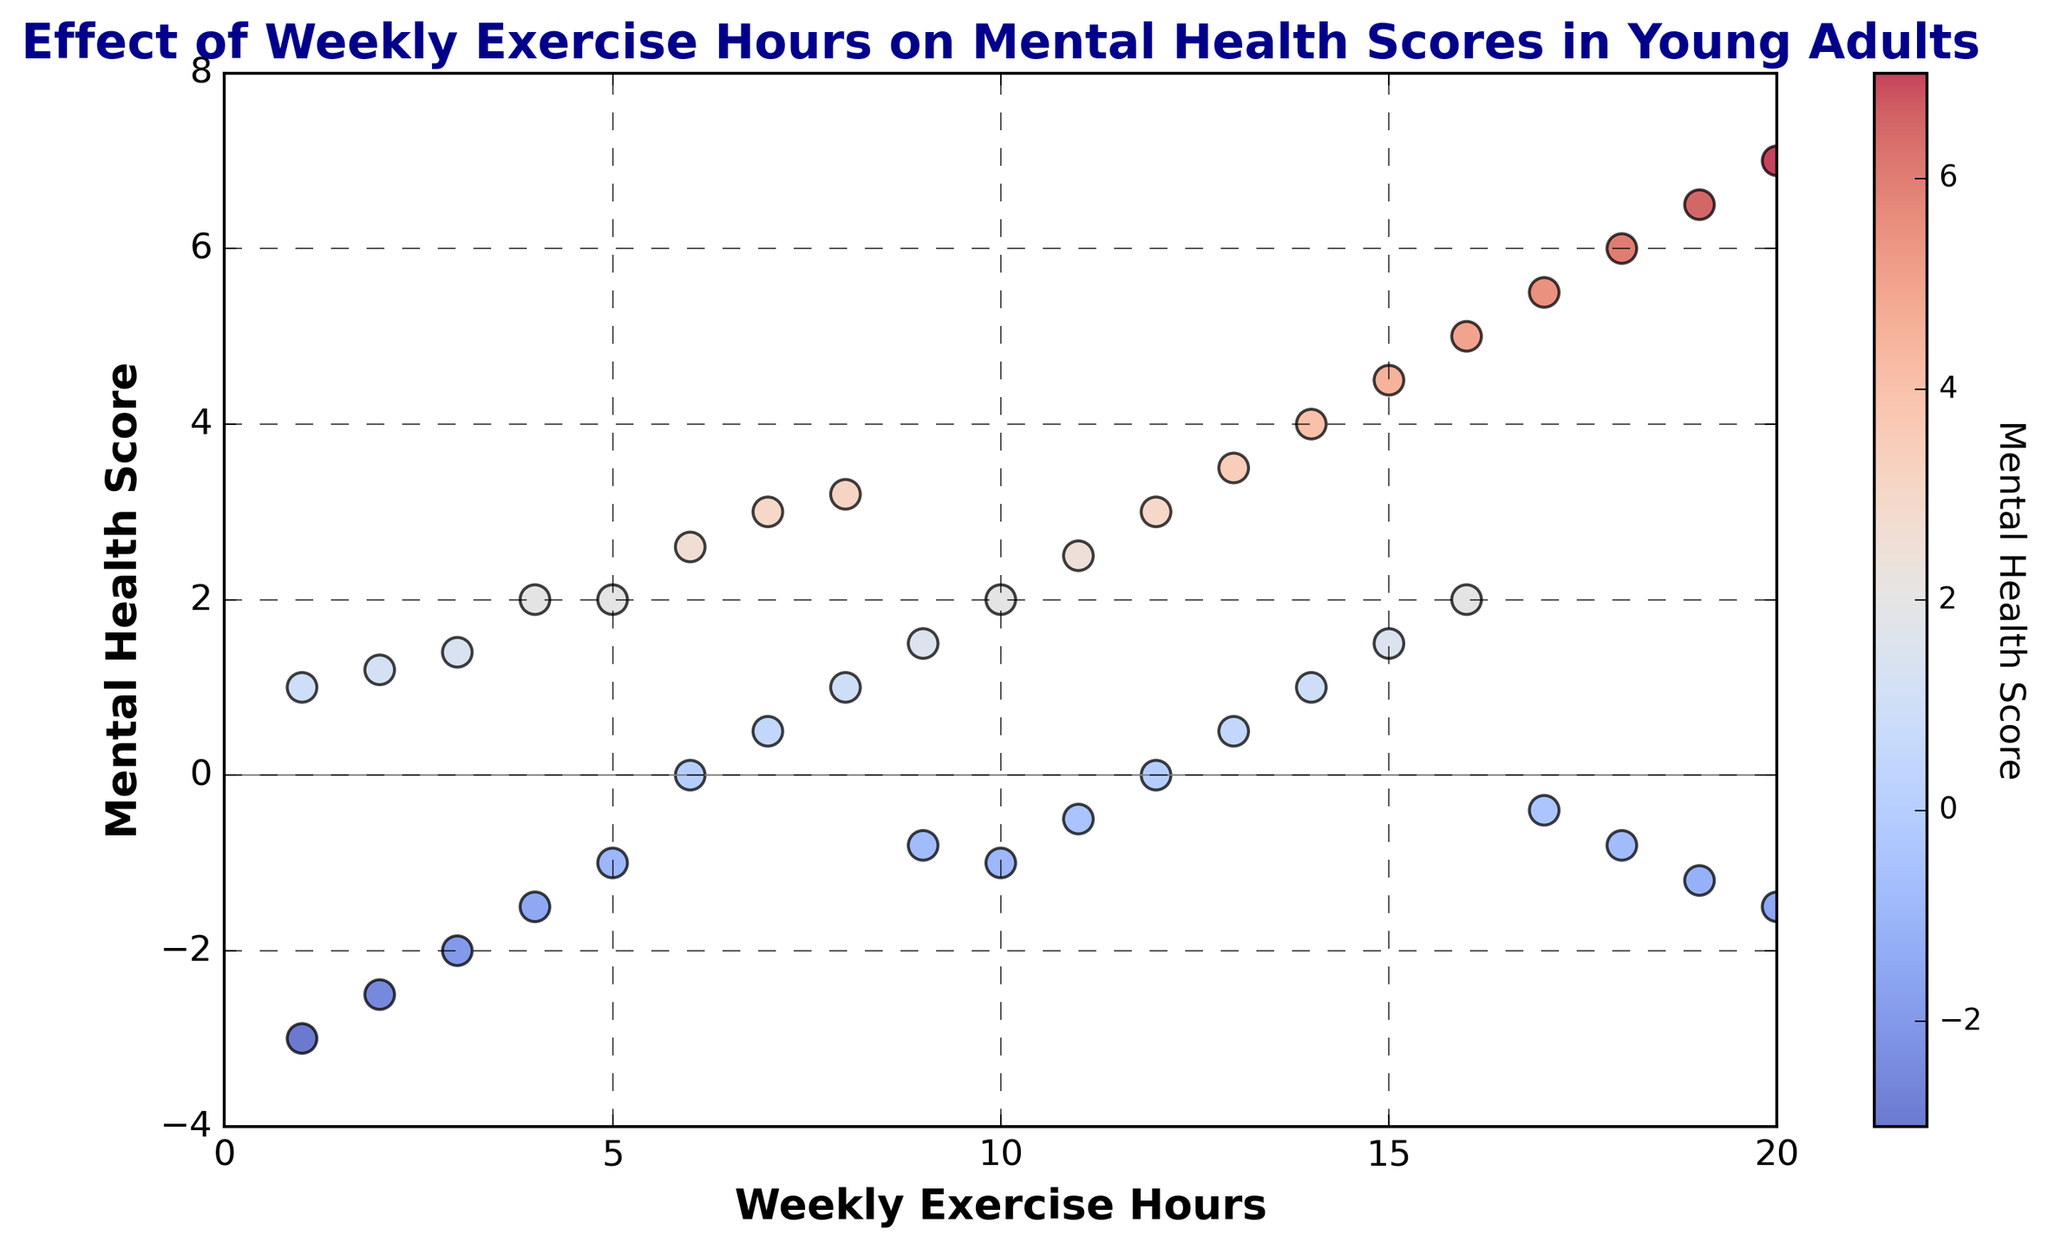What is the general trend in mental health scores as weekly exercise hours increase? As weekly exercise hours increase, the mental health scores tend to increase as well. Most data points show a positive correlation between exercising more hours and higher mental health scores. This can be observed by the rising pattern of points from left to right.
Answer: The trend is positive Identify the range of mental health scores for individuals who exercise between 5 and 10 hours per week. Observing the scatter plot, for the weekly exercise range of 5 to 10 hours, mental health scores range from -1 to 2.6. This involves seeing the vertical spread of points when the horizontal axis is between 5 and 10 hours.
Answer: -1 to 2.6 Compare the mental health scores of individuals who exercise 1 hour per week to those who exercise 20 hours per week. Looking at the plot, individuals exercising 1 hour per week generally have mental health scores of -3 and 1, whereas those exercising 20 hours per week have scores of 7 and -1.5. This comparison can be done by visually locating and comparing the scatter points for these exercise hours.
Answer: The scores are more variable at 20 hours per week (-1.5 to 7) than at 1 hour per week (-3 to 1) What is the average mental health score for individuals exercising exactly 10 hours per week? To find the average, we look at the points where weekly exercise hours are 10. We have mental health scores of 2 and -1. Adding these gives 2 + (-1) = 1, and dividing by 2 (the number of points) we get 1/2 = 0.5 as the average score.
Answer: 0.5 Do any individuals have a positive mental health score with less than 5 hours of weekly exercise? Observing the data points where the weekly exercise hours are less than 5, there is no data point with a positive mental health score. The highest score in this range is -1, which is still negative.
Answer: No Which exercise frequency shows the greatest variability in mental health scores? Examining the scatter plot, 1 hour shows the greatest variability since it has points at -3 and 1, which is a spread of 4 units. Other exercise frequencies do not show such a wide spread. One can visualize this by noting the vertical distance between the points on different 'hours' marks.
Answer: 1 hour per week How many individuals experience negative mental health scores with 10 or more hours of exercise weekly? Looking at the scatter plot, with 10 or more hours, we see negative scores at 10 hours (-1), 17 hours (-0.4), 18 hours (-0.8), 19 hours (-1.2), and 20 hours (-1.5). Counting these data points gives us 5.
Answer: 5 Are there any overlapping data points for specific exercise hours? If yes, identify one such example. There are overlapping points seen in the scatter plot at exercise hour 12, where there are two points with mental health scores of 0. This can be identified by closely observing the scatter where points overlap exactly.
Answer: Yes, at 12 hours with a score of 0 